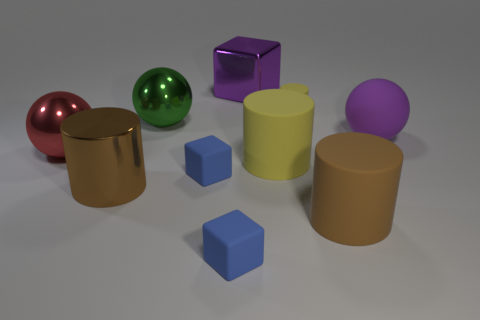Do the metal cylinder and the large rubber object in front of the brown metallic cylinder have the same color?
Provide a succinct answer. Yes. There is a large brown thing that is on the left side of the tiny rubber block that is in front of the big brown cylinder that is left of the big purple metal object; what is its shape?
Your response must be concise. Cylinder. There is a green thing; does it have the same size as the matte cylinder that is behind the large purple rubber ball?
Your response must be concise. No. What is the shape of the big object that is both to the left of the big green object and behind the large yellow thing?
Offer a very short reply. Sphere. What number of tiny things are yellow spheres or green things?
Offer a terse response. 0. Are there the same number of large green things that are to the right of the tiny yellow thing and small blue rubber blocks that are on the left side of the big brown metallic cylinder?
Keep it short and to the point. Yes. What number of other things are the same color as the small cylinder?
Your answer should be very brief. 1. Are there the same number of green metal objects in front of the large yellow object and large gray rubber things?
Offer a very short reply. Yes. There is a large object that is both behind the matte sphere and on the right side of the big green metal sphere; what is it made of?
Your answer should be compact. Metal. How many big purple things are the same shape as the big red metallic object?
Provide a short and direct response. 1. 